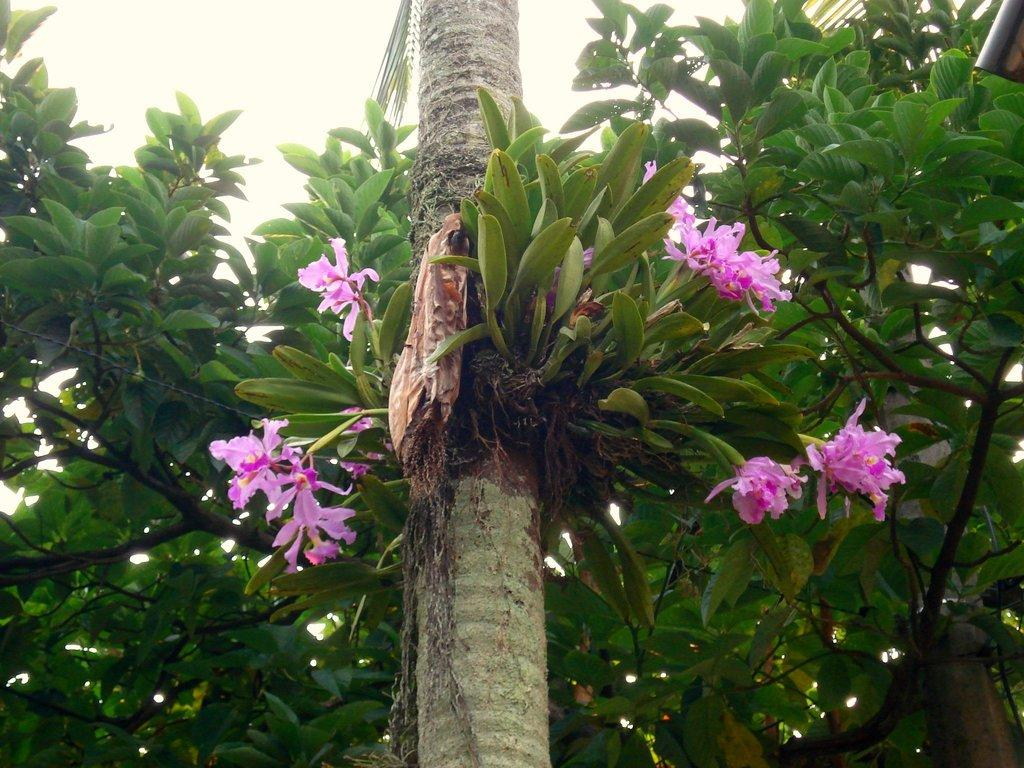What type of flora is present in the image? There are flowers in the image. What color are the flowers? The flowers are purple. What can be seen in the background of the image? There are trees in the background of the image. What color are the trees? The trees are green. How many plants are in the basin in the image? There is no basin present in the image, and therefore no plants can be found in a basin. 